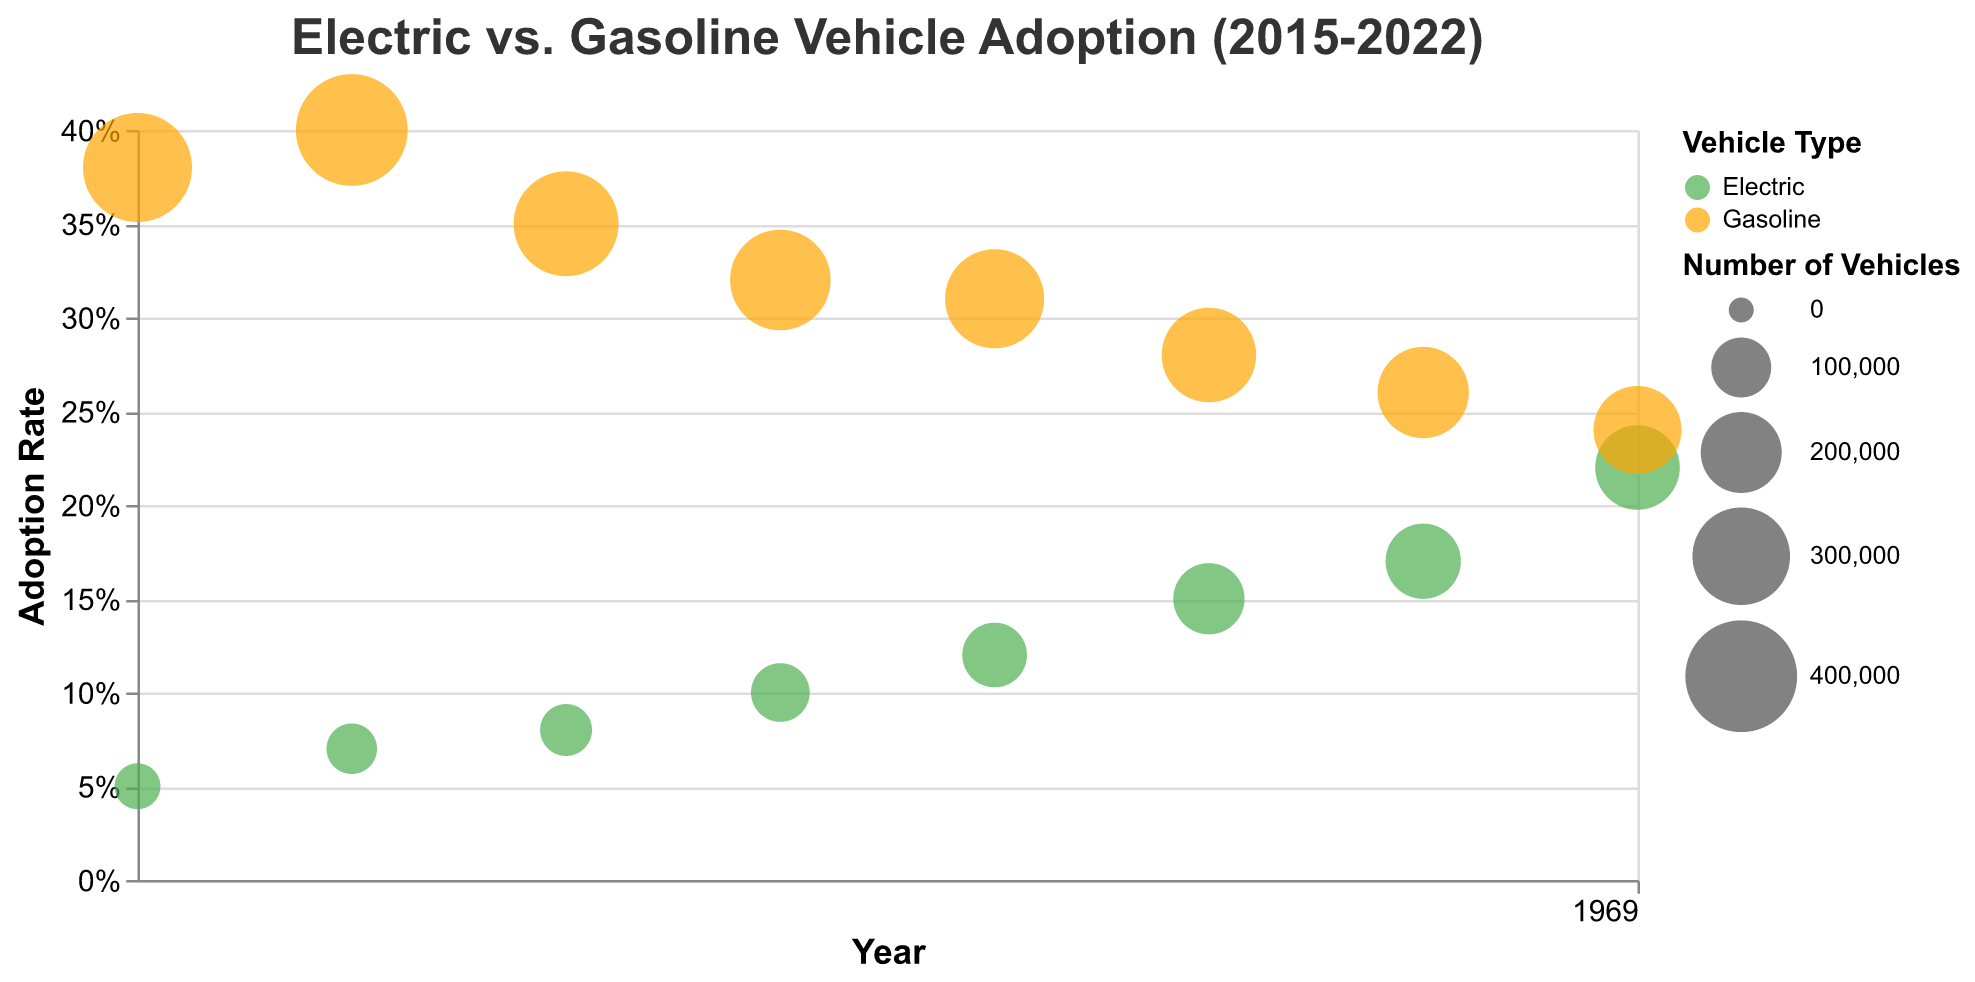How many years does the chart cover? The x-axis of the chart is labeled "Year," and the range displayed on the plot is from 2015 to 2022.
Answer: 8 years What is the adoption rate of Electric vehicles in 2022? Hovering over the bubbles for Electric vehicles in 2022 shows the adoption rate as a tooltip.
Answer: 0.22 Which vehicle type had a higher adoption rate in 2018? Compare the y-axis position of the Electric vehicle bubble and Gasoline vehicle bubble in 2018. The Electric bubble is higher on the y-axis.
Answer: Electric Which year had the highest adoption rate for Electric vehicles? Identify the Electric vehicle bubble that is highest on the y-axis across all years.
Answer: 2022 How many Electric vehicles did Tesla sell in 2015? Hover over the Electric vehicle bubble for Tesla in 2015 to see the tooltip.
Answer: 50,000 Did the number of Gasoline vehicles sold by Ford increase or decrease from 2015 to 2020? Hover over the bubbles for Gasoline vehicles by Ford in 2015 and 2020 to compare the "Number of Vehicles" in the tooltip. The number of vehicles decreased.
Answer: Decrease Which year had the smallest bubble for Electric vehicles? By comparing the size of bubbles for Electric vehicles across all years, the smallest one is in 2015.
Answer: 2015 What is the difference in the number of vehicles sold between Electric and Gasoline vehicles in 2021? Hover over the bubbles for Electric (Volkswagen) and Gasoline (Chevrolet) vehicles in 2021. Subtract the number of vehicles sold for Electric vehicles (170,000) from Gasoline vehicles (260,000).
Answer: 90,000 What is the average price of Electric vehicles sold by Tesla in 2022? Hover over the Tesla bubble in 2022 to see the tooltip for "Average Price ($)."
Answer: $72,000 